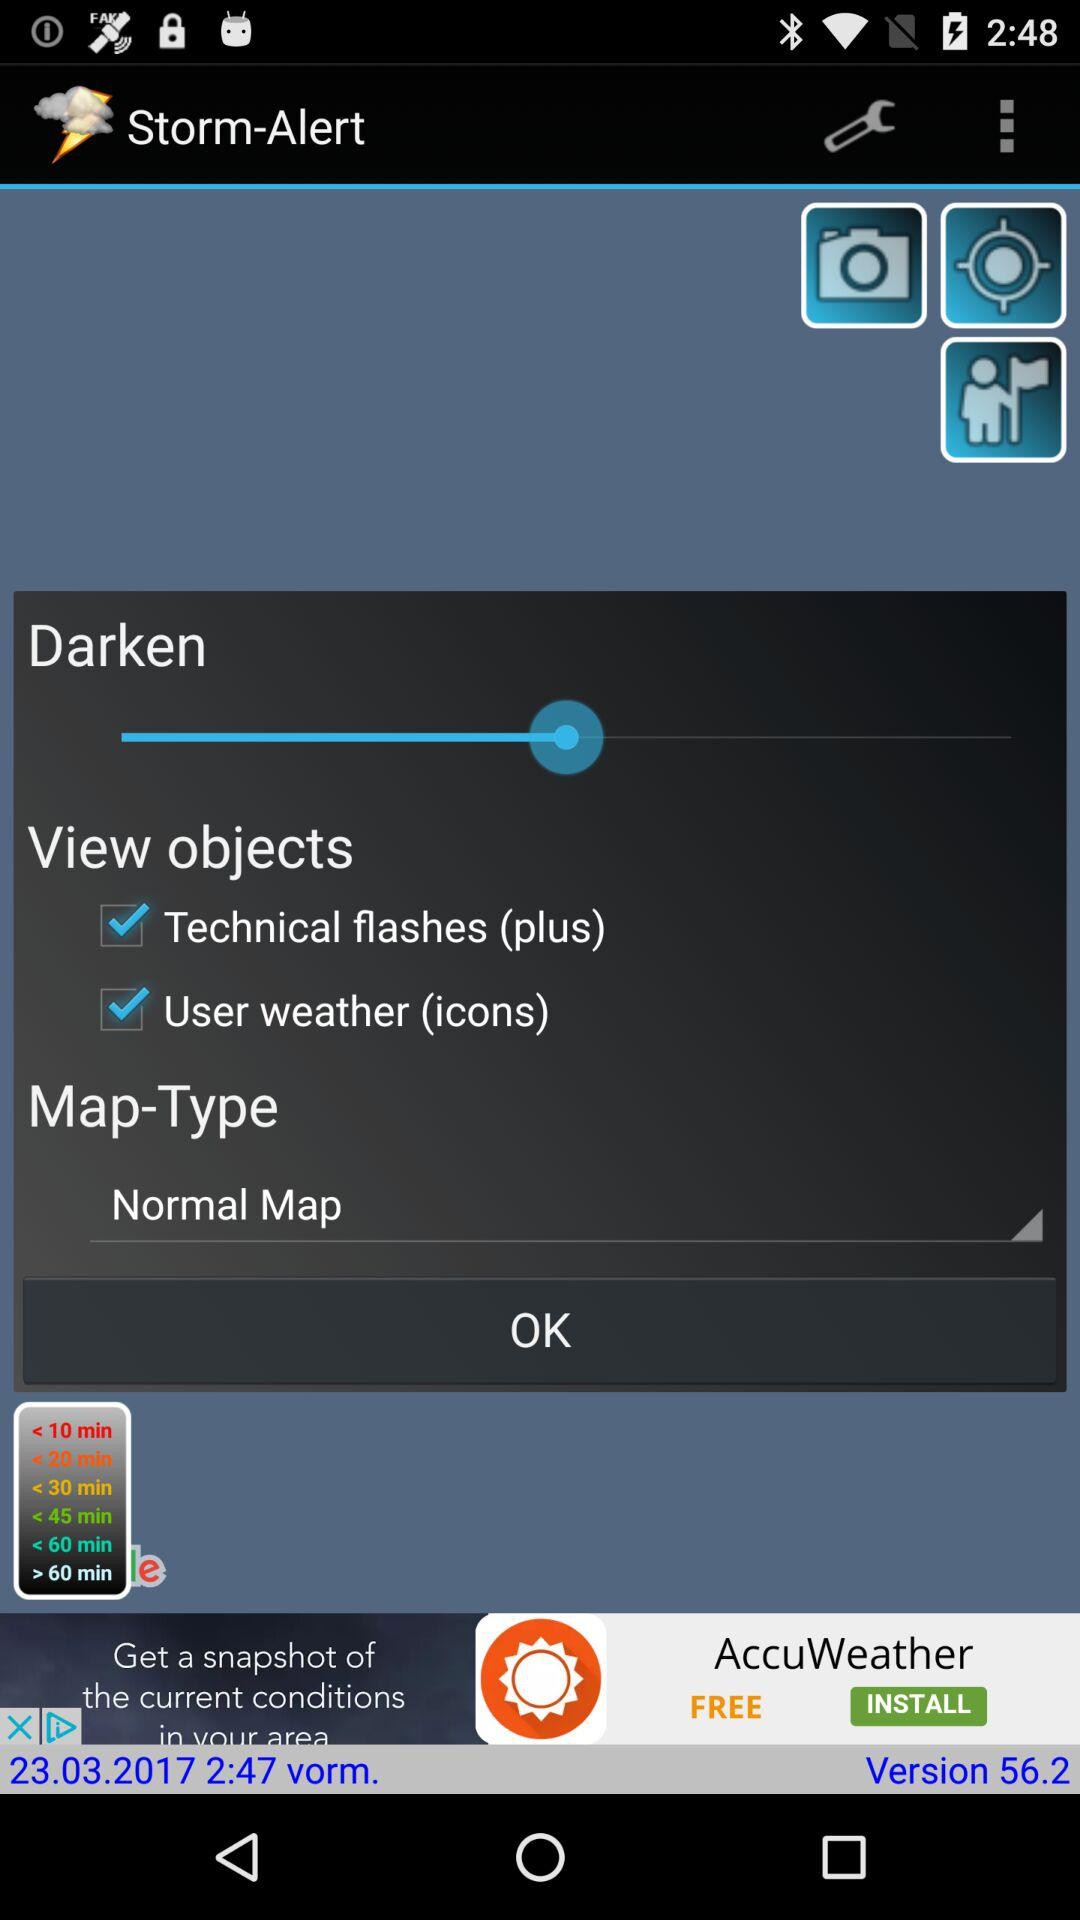How many more minutes are there in 60 minutes than in 20 minutes?
Answer the question using a single word or phrase. 40 